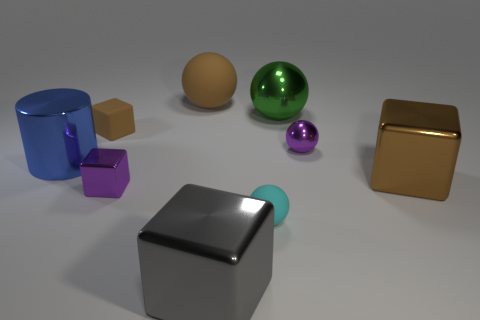What number of gray cubes have the same material as the big green thing?
Your answer should be compact. 1. How many things are matte balls or brown cylinders?
Your answer should be very brief. 2. Are any cylinders visible?
Your answer should be compact. Yes. The tiny cube in front of the large brown metallic cube in front of the brown cube that is to the left of the purple ball is made of what material?
Your answer should be compact. Metal. Is the number of large cylinders in front of the big cylinder less than the number of tiny purple metal things?
Your answer should be compact. Yes. There is another purple block that is the same size as the matte cube; what is it made of?
Ensure brevity in your answer.  Metal. What is the size of the metallic object that is both in front of the blue metallic thing and right of the big gray cube?
Offer a terse response. Large. There is a green metallic thing that is the same shape as the tiny cyan object; what size is it?
Offer a very short reply. Large. How many objects are large red cubes or large metallic objects behind the small cyan matte ball?
Keep it short and to the point. 3. What is the shape of the green thing?
Offer a very short reply. Sphere. 